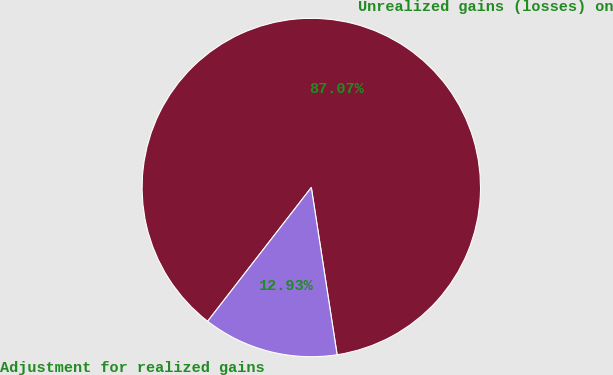Convert chart. <chart><loc_0><loc_0><loc_500><loc_500><pie_chart><fcel>Unrealized gains (losses) on<fcel>Adjustment for realized gains<nl><fcel>87.07%<fcel>12.93%<nl></chart> 